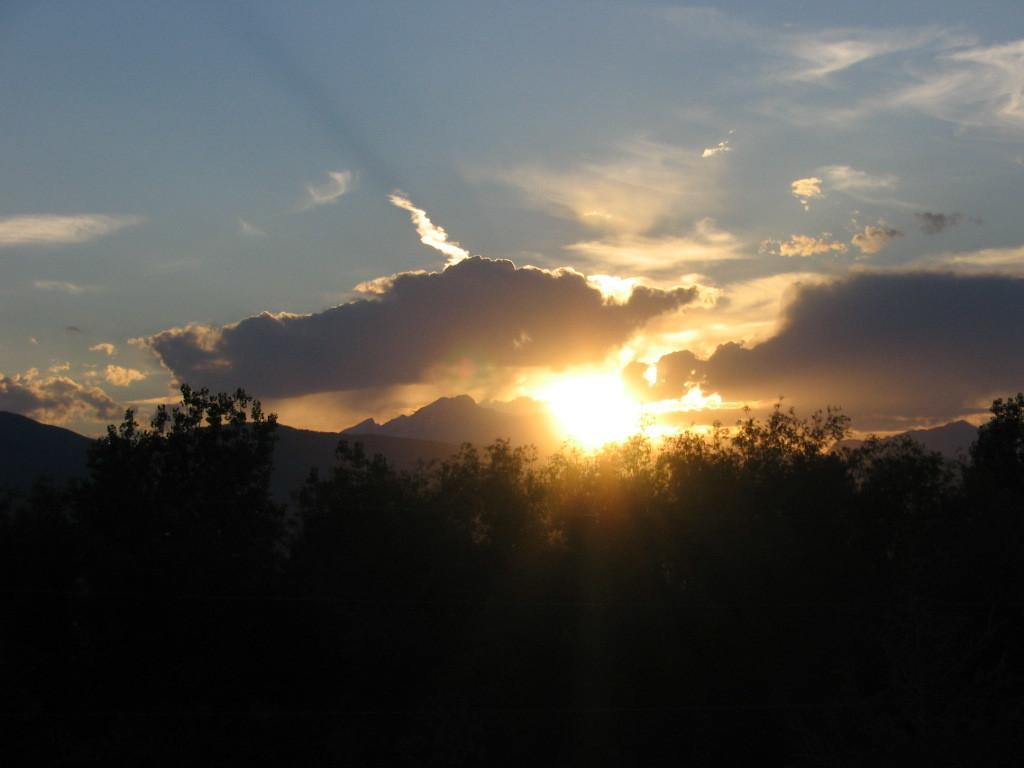Could you give a brief overview of what you see in this image? In the picture we can see some plants and behind it, we can see hills and sky with clouds and sunshine. 